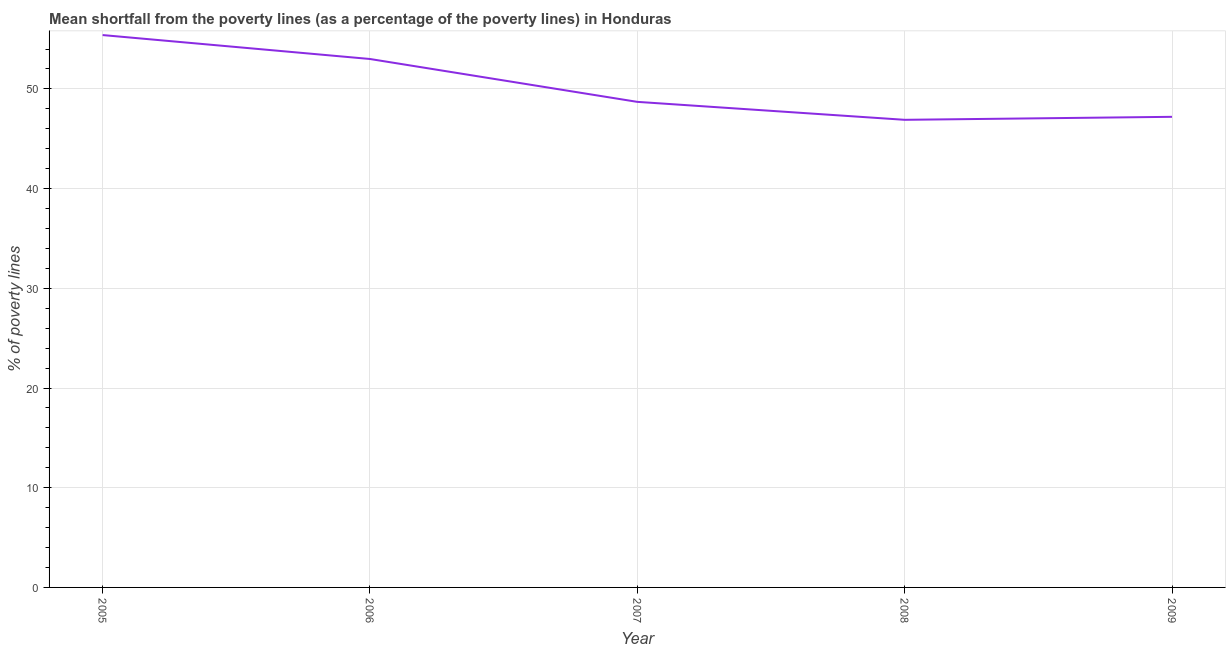What is the poverty gap at national poverty lines in 2009?
Provide a short and direct response. 47.2. Across all years, what is the maximum poverty gap at national poverty lines?
Offer a terse response. 55.4. Across all years, what is the minimum poverty gap at national poverty lines?
Provide a short and direct response. 46.9. What is the sum of the poverty gap at national poverty lines?
Make the answer very short. 251.2. What is the difference between the poverty gap at national poverty lines in 2005 and 2008?
Provide a succinct answer. 8.5. What is the average poverty gap at national poverty lines per year?
Ensure brevity in your answer.  50.24. What is the median poverty gap at national poverty lines?
Keep it short and to the point. 48.7. What is the ratio of the poverty gap at national poverty lines in 2008 to that in 2009?
Your answer should be compact. 0.99. Is the difference between the poverty gap at national poverty lines in 2005 and 2008 greater than the difference between any two years?
Your answer should be very brief. Yes. What is the difference between the highest and the second highest poverty gap at national poverty lines?
Your response must be concise. 2.4. What is the difference between the highest and the lowest poverty gap at national poverty lines?
Your answer should be very brief. 8.5. In how many years, is the poverty gap at national poverty lines greater than the average poverty gap at national poverty lines taken over all years?
Provide a short and direct response. 2. Does the poverty gap at national poverty lines monotonically increase over the years?
Make the answer very short. No. How many lines are there?
Give a very brief answer. 1. Are the values on the major ticks of Y-axis written in scientific E-notation?
Provide a short and direct response. No. What is the title of the graph?
Your answer should be compact. Mean shortfall from the poverty lines (as a percentage of the poverty lines) in Honduras. What is the label or title of the X-axis?
Your response must be concise. Year. What is the label or title of the Y-axis?
Your answer should be very brief. % of poverty lines. What is the % of poverty lines in 2005?
Your answer should be compact. 55.4. What is the % of poverty lines in 2006?
Give a very brief answer. 53. What is the % of poverty lines of 2007?
Provide a succinct answer. 48.7. What is the % of poverty lines in 2008?
Your answer should be compact. 46.9. What is the % of poverty lines of 2009?
Offer a very short reply. 47.2. What is the difference between the % of poverty lines in 2005 and 2006?
Offer a very short reply. 2.4. What is the difference between the % of poverty lines in 2006 and 2007?
Provide a succinct answer. 4.3. What is the difference between the % of poverty lines in 2006 and 2008?
Your answer should be compact. 6.1. What is the difference between the % of poverty lines in 2007 and 2008?
Provide a succinct answer. 1.8. What is the difference between the % of poverty lines in 2007 and 2009?
Ensure brevity in your answer.  1.5. What is the difference between the % of poverty lines in 2008 and 2009?
Your response must be concise. -0.3. What is the ratio of the % of poverty lines in 2005 to that in 2006?
Keep it short and to the point. 1.04. What is the ratio of the % of poverty lines in 2005 to that in 2007?
Offer a very short reply. 1.14. What is the ratio of the % of poverty lines in 2005 to that in 2008?
Provide a succinct answer. 1.18. What is the ratio of the % of poverty lines in 2005 to that in 2009?
Your response must be concise. 1.17. What is the ratio of the % of poverty lines in 2006 to that in 2007?
Your answer should be very brief. 1.09. What is the ratio of the % of poverty lines in 2006 to that in 2008?
Your answer should be very brief. 1.13. What is the ratio of the % of poverty lines in 2006 to that in 2009?
Offer a very short reply. 1.12. What is the ratio of the % of poverty lines in 2007 to that in 2008?
Keep it short and to the point. 1.04. What is the ratio of the % of poverty lines in 2007 to that in 2009?
Offer a very short reply. 1.03. 